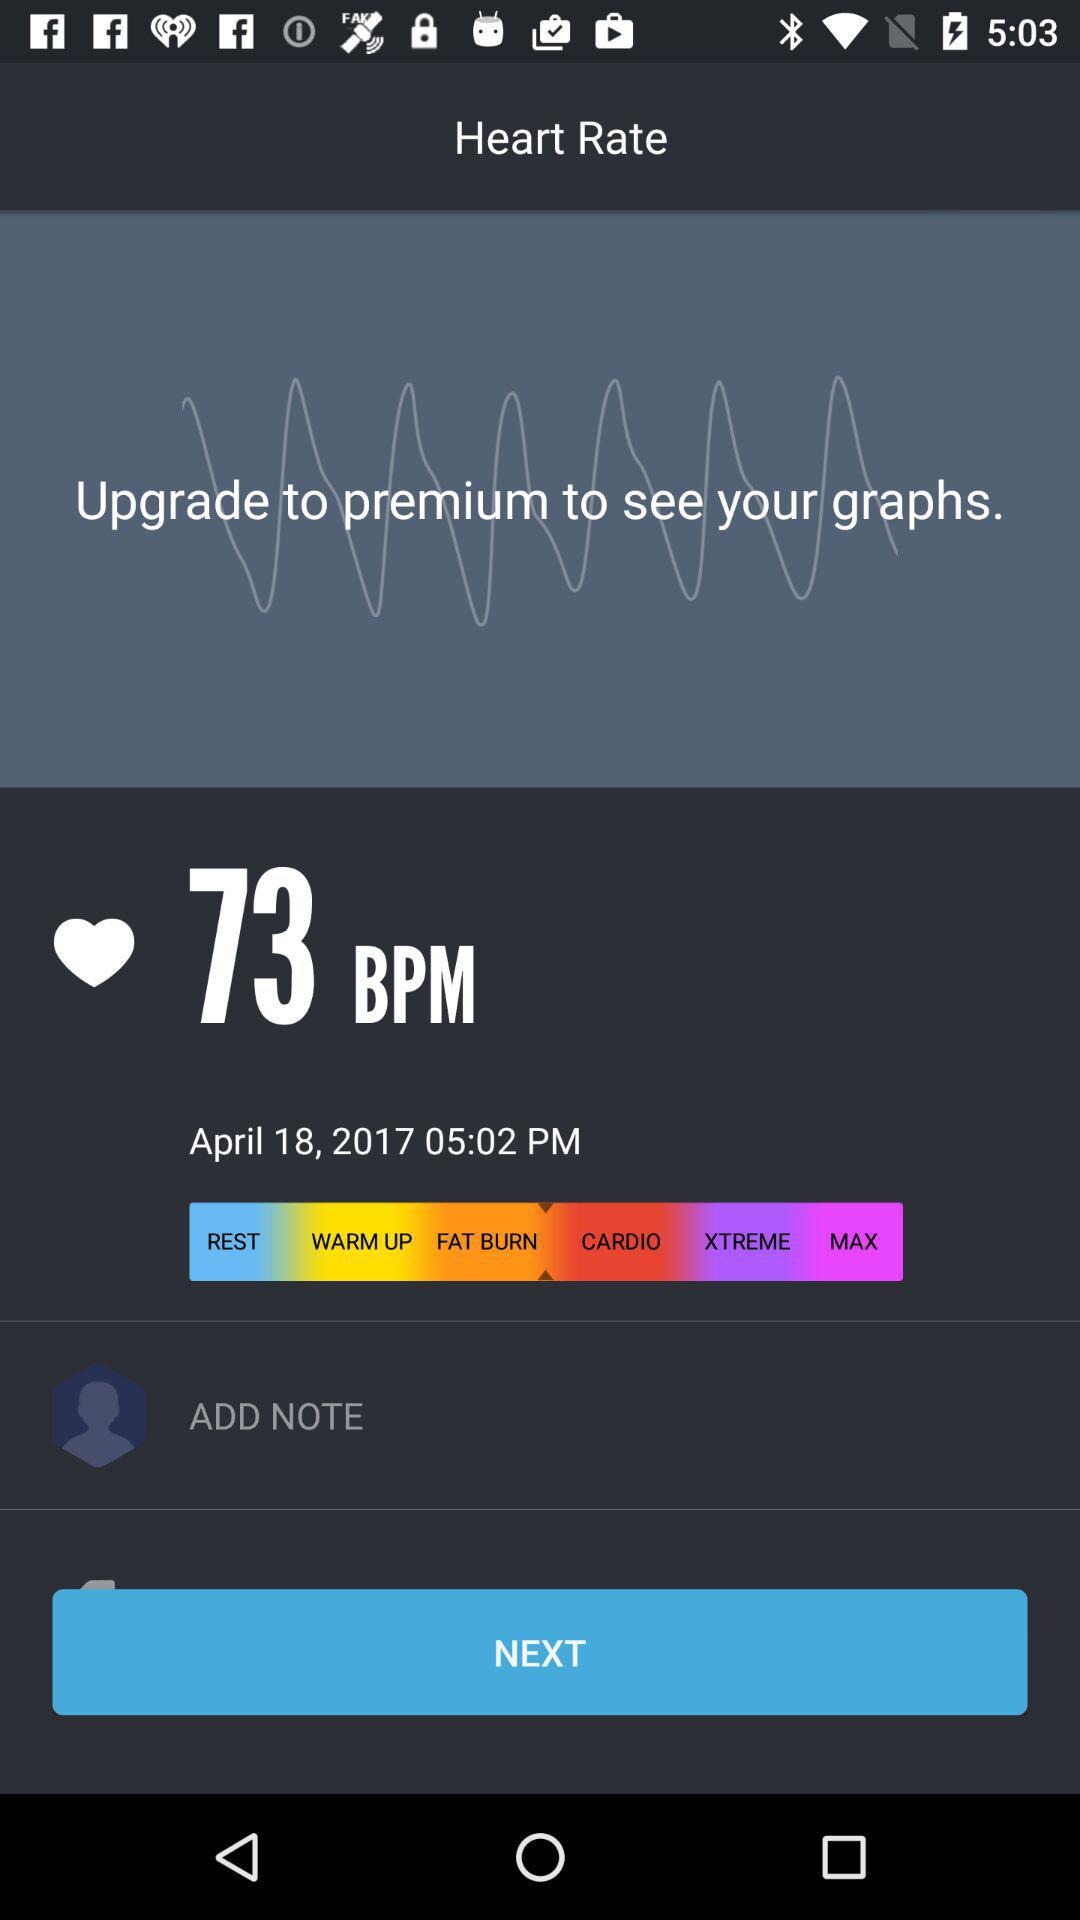What is the date and time of the measurement?
Answer the question using a single word or phrase. April 18, 2017 05:02 PM 